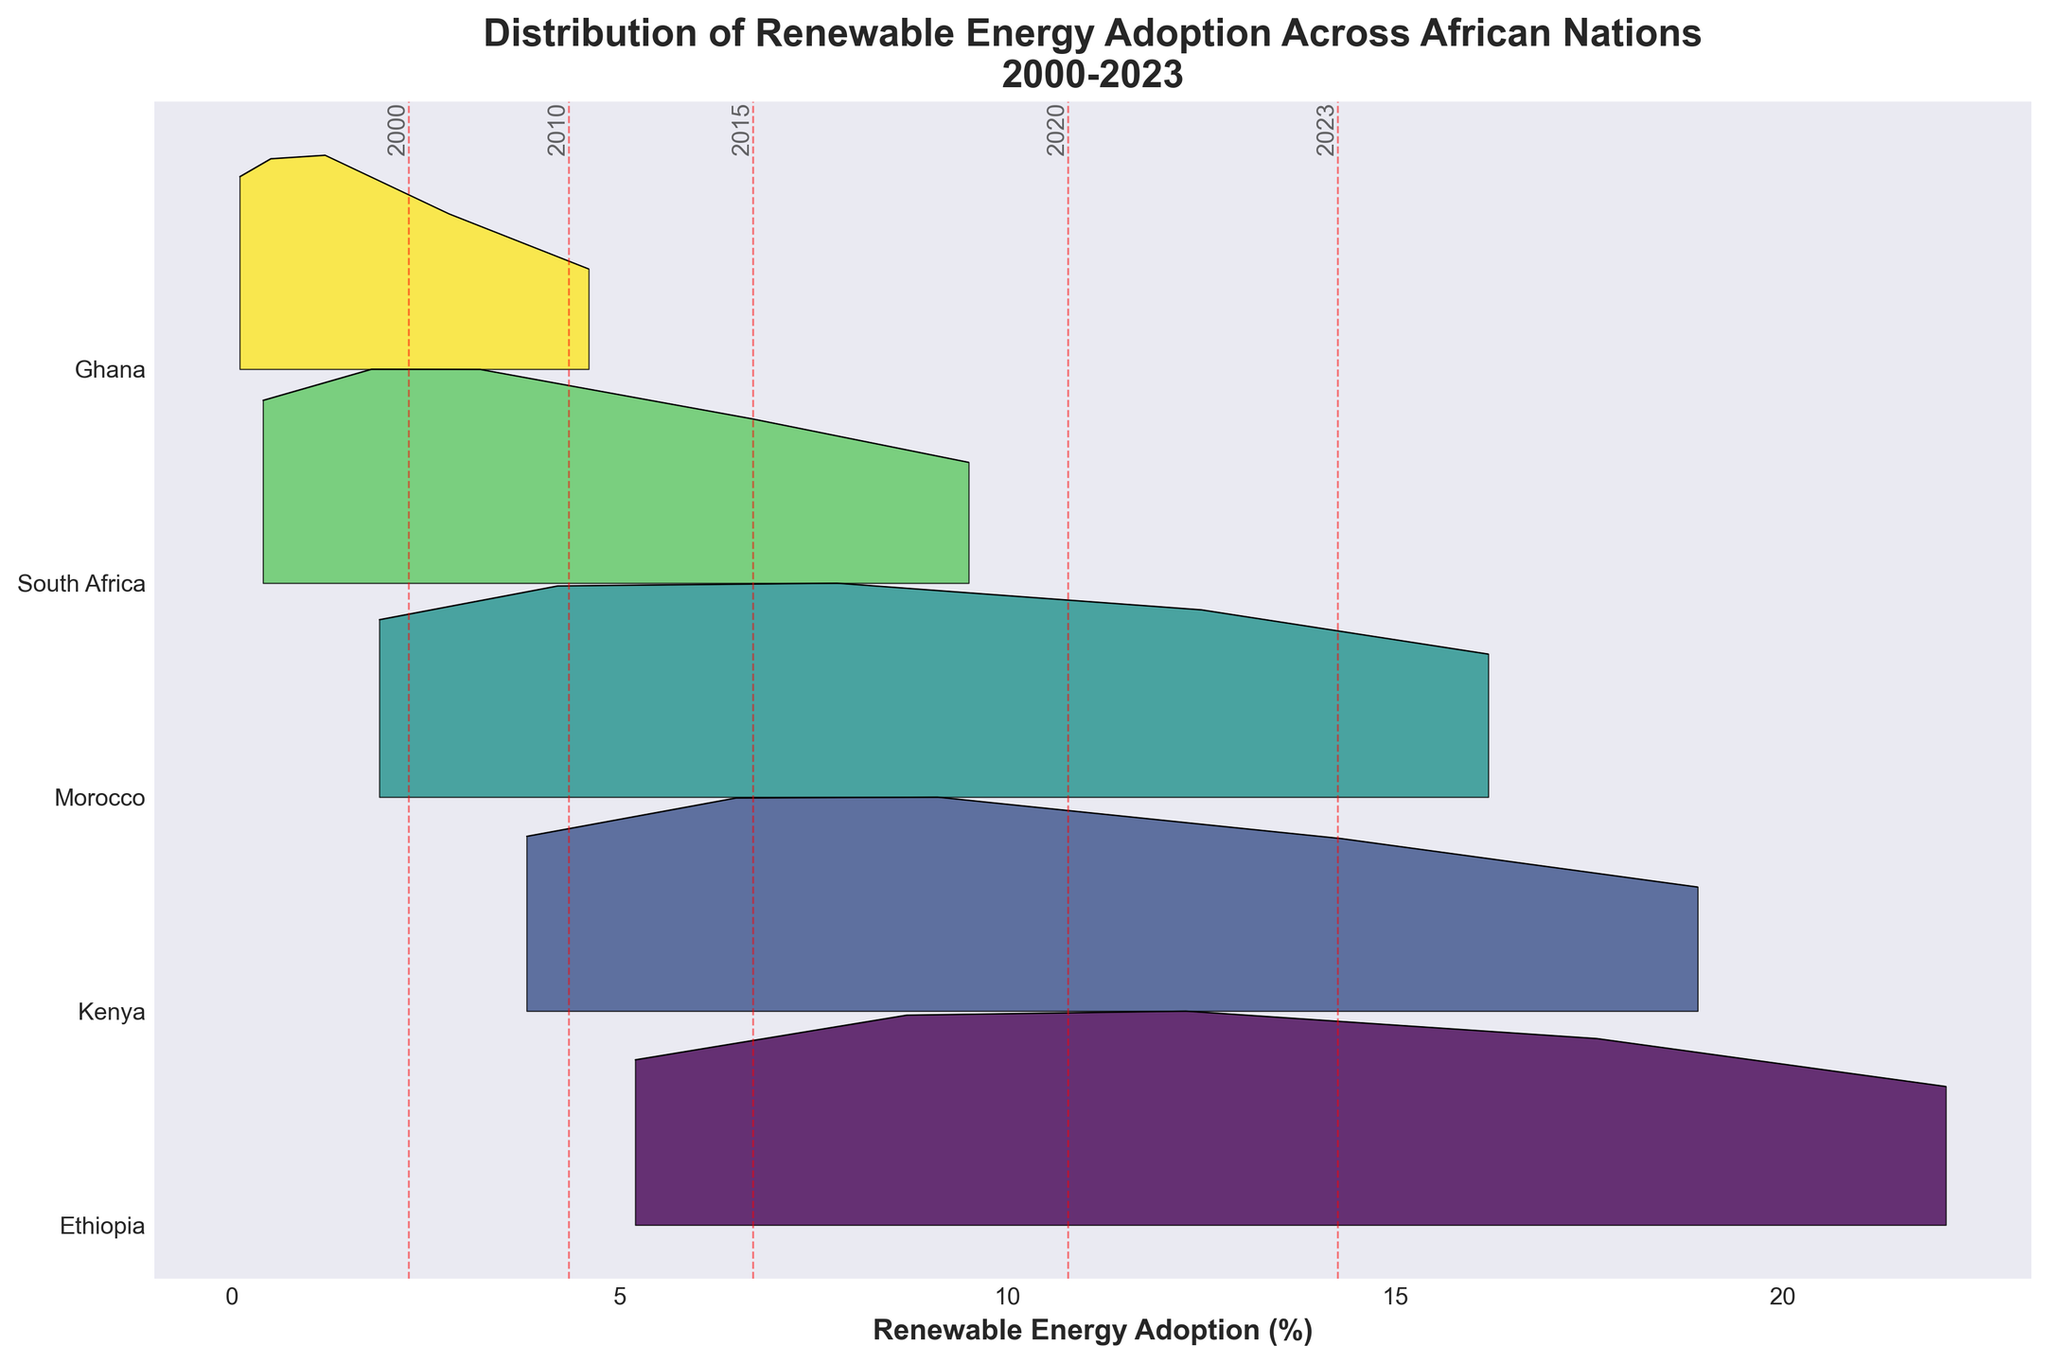What is the title of the figure? The title is the large, bold text at the top of the figure. It is designed to provide a summary of what the figure is about.
Answer: Distribution of Renewable Energy Adoption Across African Nations 2000-2023 Which country shows the highest renewable energy adoption in 2023? To find this, look for the peak point in the 2023 section of the ridgeline plot and check which country it aligns with on the y-axis.
Answer: Ethiopia How does the renewable energy adoption of Ghana compare between 2000 and 2023? From the ridgeline plot, identify Ghana's line and compare its peaks between 2000 and 2023.
Answer: It increased from 0.1% to 4.6% Which year has the highest mean renewable energy adoption across all countries? Look for the vertical dashed lines representing the mean renewable energy adoption for each year. The line that has the highest position on the x-axis indicates the year with the highest mean.
Answer: 2023 How does Ethiopia's renewable energy adoption trend from 2000 to 2023 appear? Follow the peaks of Ethiopia along the years from 2000 to 2023 on the ridgeline plot to observe the trend.
Answer: Increasing Is there any country whose renewable energy adoption did not increase every year? Check each country's trend on the ridgeline plot. There should be consistent upward movements without any dips if a country's adoption did not increase every year.
Answer: No, all countries show an increase every year What's the average renewable energy adoption in 2015 across all countries? Sum the adoption percentages for all countries in 2015 and divide by the number of countries: (12.3 + 9.1 + 7.8 + 3.2 + 1.2) / 5.
Answer: 6.72% Which country had the lowest renewable energy adoption in 2000? Find the least peak value in the 2000 section and check which country it aligns with on the y-axis.
Answer: Ghana How does Morocco's renewable energy adoption in 2020 compare to Kenya's in the same year? Locate the peaks for Morocco and Kenya in 2020 and compare their x-axis positions.
Answer: Morocco (12.5%) is lower than Kenya (14.3%) Which country shows the steadiest increase in renewable energy adoption over the years? A steady increase would display as a smooth upward trend without any sharp increases or plateaus. Visual inspection can help determine which country maintains a consistent upward slope.
Answer: Ethiopia 